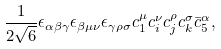Convert formula to latex. <formula><loc_0><loc_0><loc_500><loc_500>\frac { 1 } { 2 \sqrt { 6 } } \epsilon _ { \alpha \beta \gamma } \epsilon _ { \beta \mu \nu } \epsilon _ { \gamma \rho \sigma } c _ { 1 } ^ { \mu } c _ { i } ^ { \nu } c _ { j } ^ { \rho } c _ { k } ^ { \sigma } \bar { c } _ { 5 } ^ { \alpha } ,</formula> 